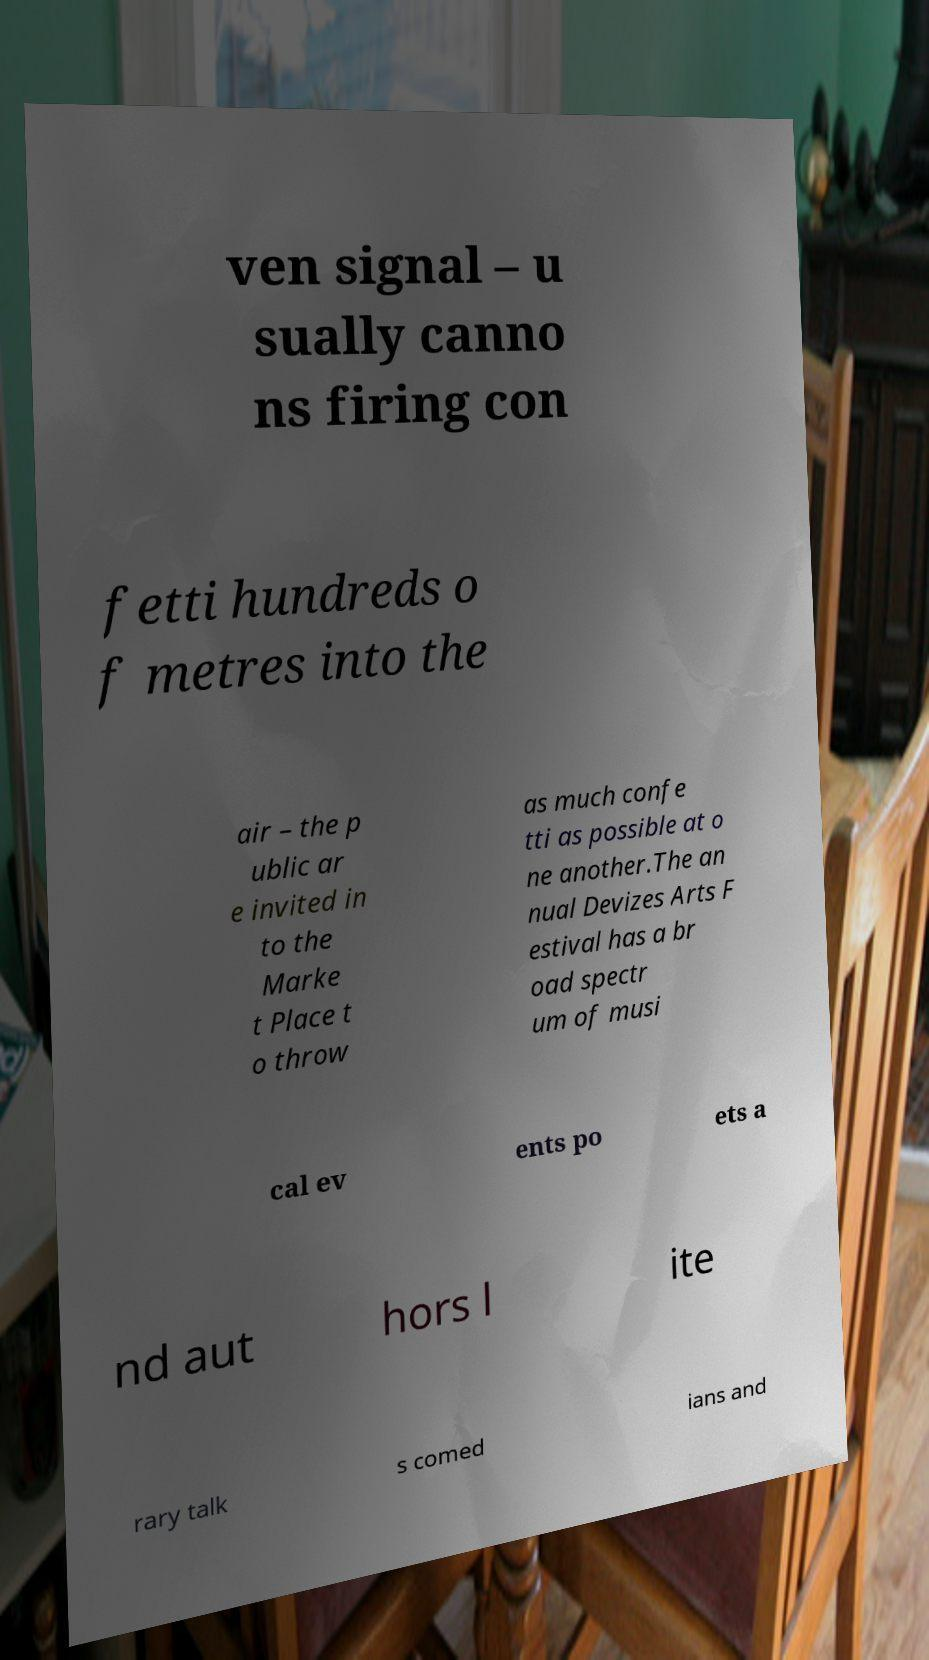Could you assist in decoding the text presented in this image and type it out clearly? ven signal – u sually canno ns firing con fetti hundreds o f metres into the air – the p ublic ar e invited in to the Marke t Place t o throw as much confe tti as possible at o ne another.The an nual Devizes Arts F estival has a br oad spectr um of musi cal ev ents po ets a nd aut hors l ite rary talk s comed ians and 